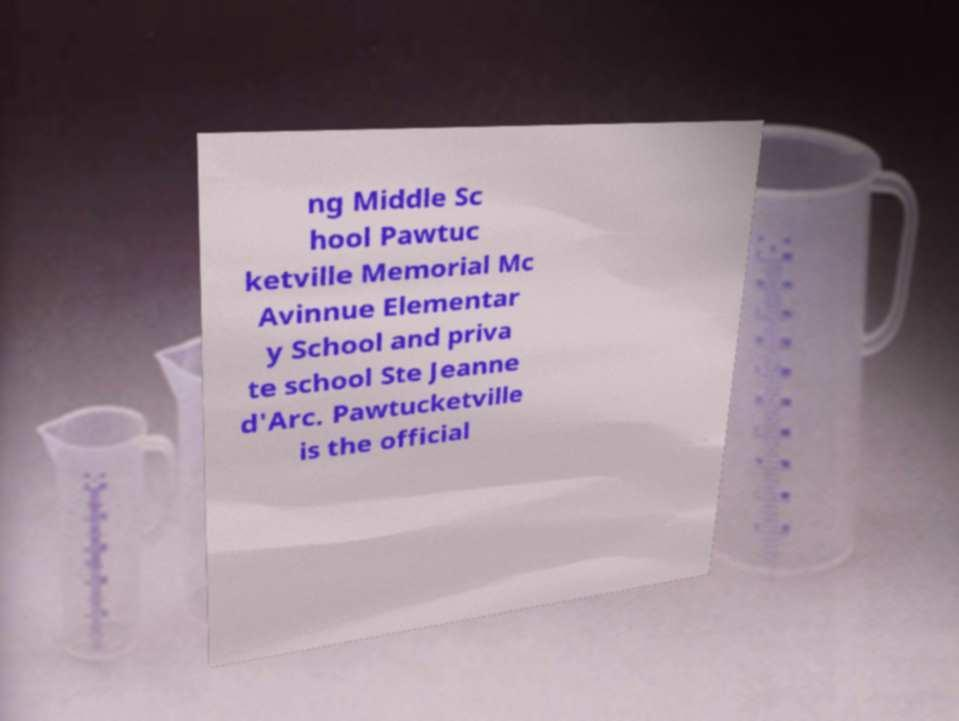Can you read and provide the text displayed in the image?This photo seems to have some interesting text. Can you extract and type it out for me? ng Middle Sc hool Pawtuc ketville Memorial Mc Avinnue Elementar y School and priva te school Ste Jeanne d'Arc. Pawtucketville is the official 